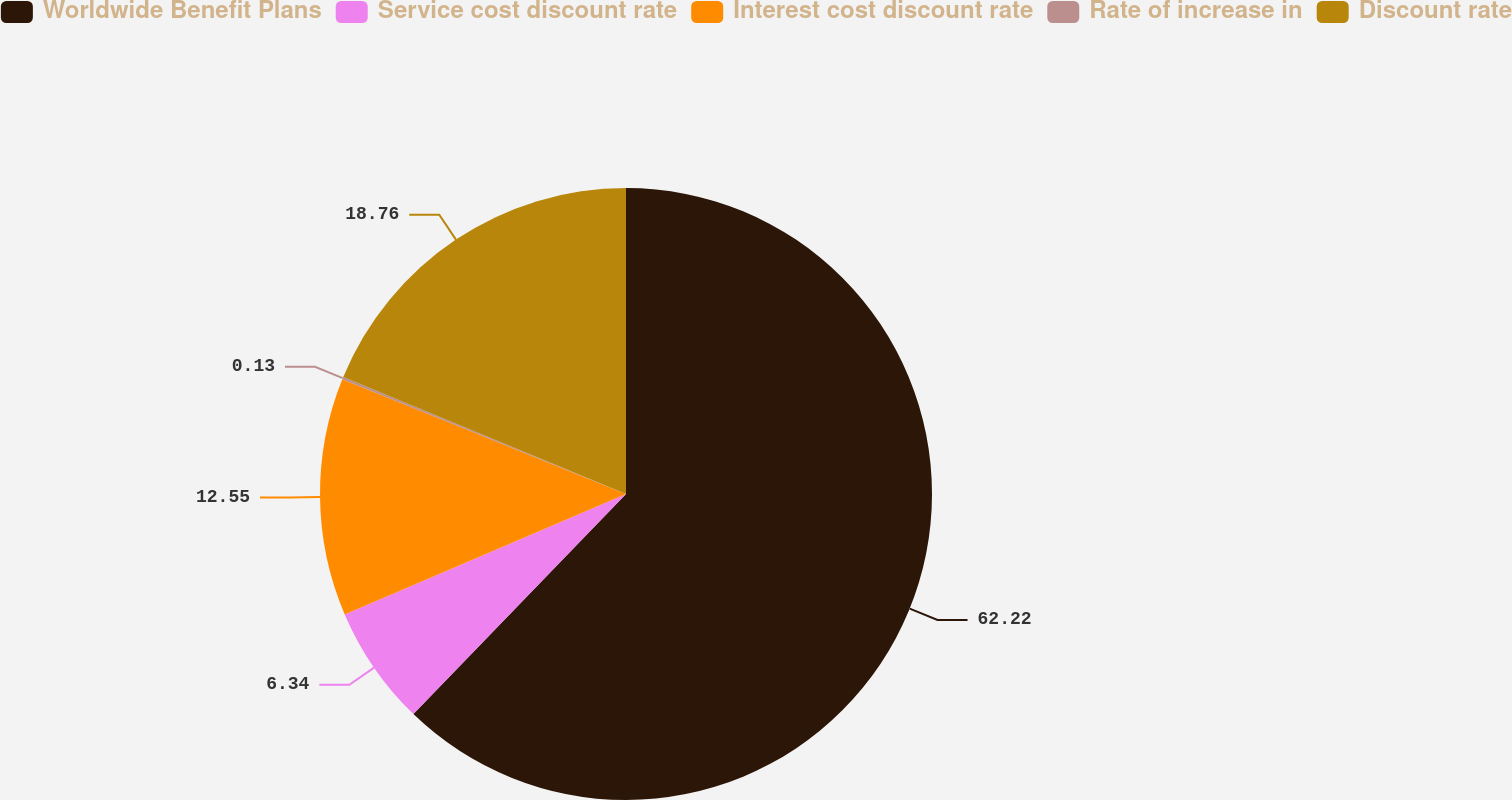Convert chart to OTSL. <chart><loc_0><loc_0><loc_500><loc_500><pie_chart><fcel>Worldwide Benefit Plans<fcel>Service cost discount rate<fcel>Interest cost discount rate<fcel>Rate of increase in<fcel>Discount rate<nl><fcel>62.23%<fcel>6.34%<fcel>12.55%<fcel>0.13%<fcel>18.76%<nl></chart> 